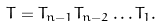<formula> <loc_0><loc_0><loc_500><loc_500>T = T _ { n - 1 } T _ { n - 2 } \dots T _ { 1 } .</formula> 